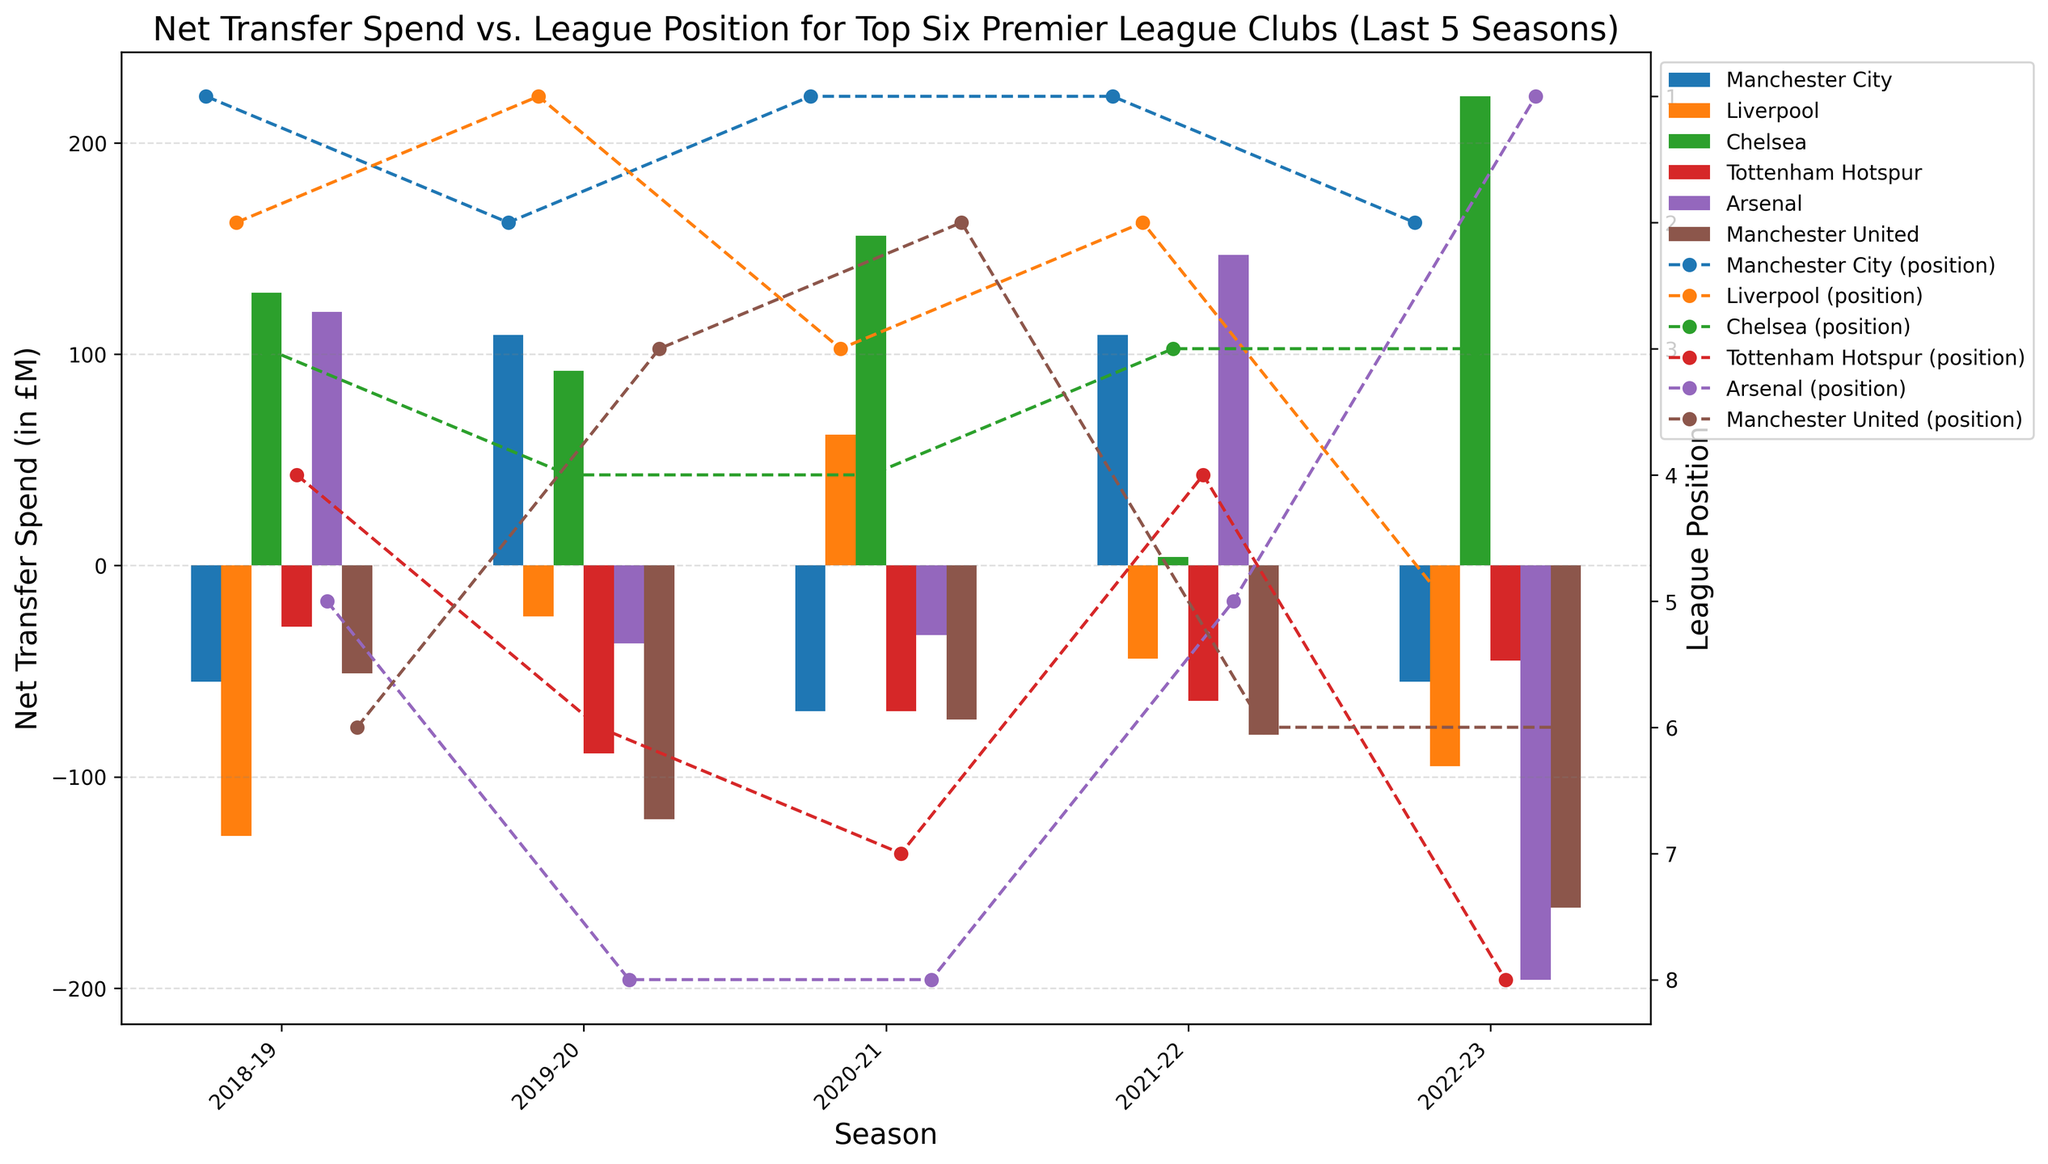What's the total net transfer spend for Tottenham Hotspur over the five seasons? To calculate the total net transfer spend for Tottenham Hotspur, sum the net transfer spend for each season: -29 (2018-19) + (-89) (2019-20) + (-69) (2020-21) + (-64) (2021-22) + (-45) (2022-23) = -296
Answer: -296 Which club had the highest net transfer spend in the 2021-22 season? To find the highest net transfer spend in the 2021-22 season, compare the net transfer spend among the clubs: Manchester City (109), Liverpool (-44), Chelsea (4), Tottenham Hotspur (-64), Arsenal (147), Manchester United (-80). Arsenal had the highest spend.
Answer: Arsenal In which seasons did Liverpool have a net transfer spend of less than -50 million? Identify the seasons where Liverpool's net transfer spend was less than -50 million: 2018-19 (-128) and 2022-23 (-95). These were the seasons.
Answer: 2018-19 and 2022-23 How did Arsenal's net transfer spend in 2021-22 compare to 2022-23? Compare Arsenal's net transfer spend in 2021-22 (147) with that in 2022-23 (-196). The spend decreased from 147 to -196, indicating a significant reduction.
Answer: Decreased significantly What were Manchester City's league positions and net transfer spend in the 2020-21 season? For the 2020-21 season, Manchester City's league position was 1st and their net transfer spend was -69 million. This information is extracted directly from the provided data.
Answer: 1st, -69 Which season had the highest overall net transfer spend among all clubs? Add the net transfer spends of all clubs for each season and compare: The sums are: 2018-19: -14, 2019-20: -69, 2020-21: -26, 2021-22: 72, 2022-23: -331. The season with the highest overall net transfer spend is 2021-22 with 72 million.
Answer: 2021-22 How did Tottenham Hotspur perform in terms of league position versus their net transfer spend in 2019-20? Tottenham's net transfer spend in 2019-20 was -89 million, and their league position was 6th. Analyzing the bar chart and line, it shows they spent less but ended in a low position.
Answer: 6th with -89 million Which club had the most consistent net transfer spend (smallest variance) over the five seasons? Calculate the variance of net transfer spend for each club, comparing their consistency. Manchester City: -55, 109, -69, 109, -55. Variance is relatively low compared to other clubs.
Answer: Manchester City Compare the net transfer spend of Chelsea and Manchester United in the 2022-23 season. For the 2022-23 season, Chelsea's net transfer spend was 222 million, and Manchester United's was -162 million. Chelsea's spend is higher.
Answer: Chelsea spent more Which clubs had positive net transfer spend in the 2018-19 season and what were their league positions? Identify clubs with positive net transfer spend in 2018-19: Chelsea (129) and Arsenal (120). Their league positions were 3rd and 5th respectively.
Answer: Chelsea (3rd), Arsenal (5th) 